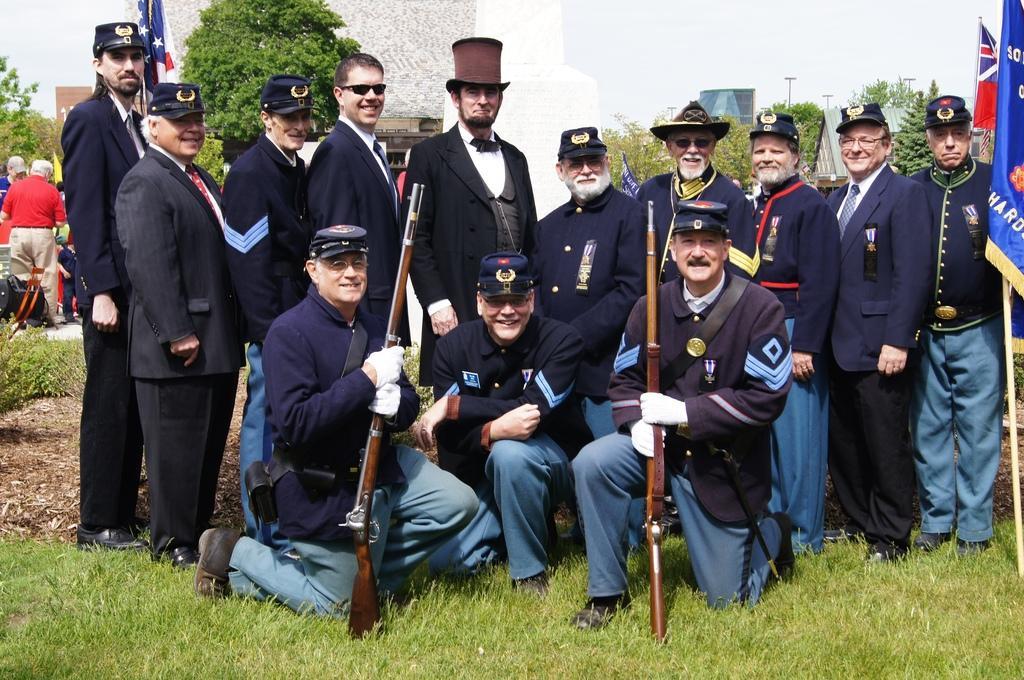In one or two sentences, can you explain what this image depicts? In this picture there are people smiling, among them there are two men sitting like squat position and holding guns and we can see flags, grass and plants. In the background of the image we can see people, trees, poles, wall and sky. 